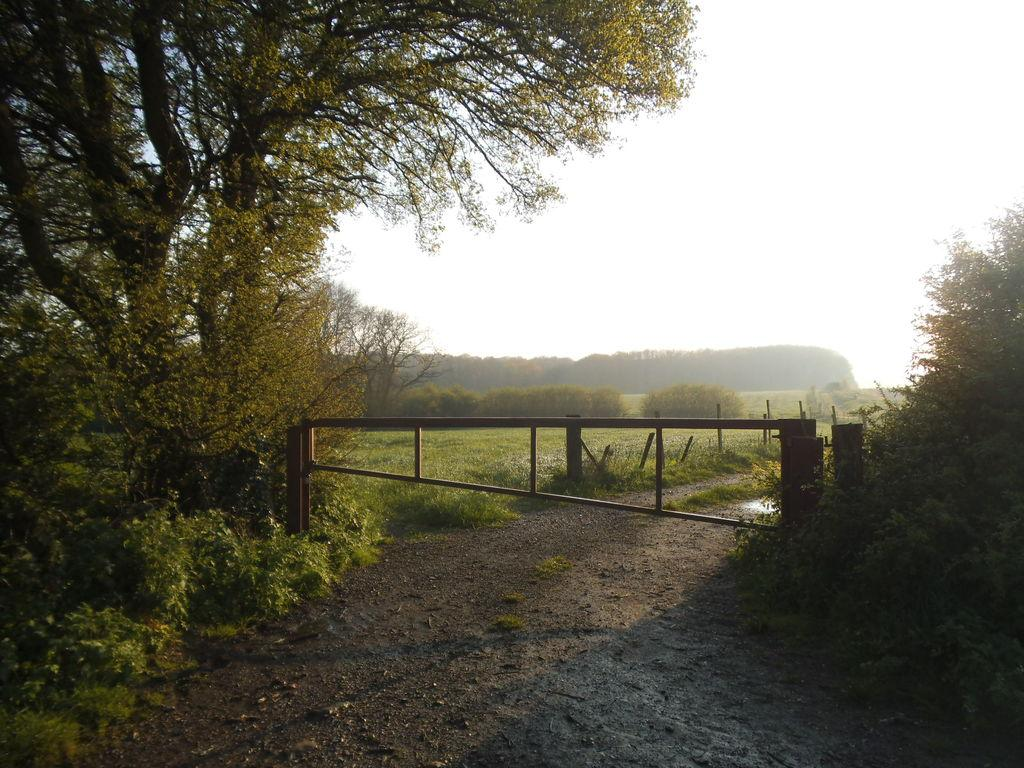What type of vegetation can be seen in the image? There are trees, shrubs, and bushes in the image. What part of the natural environment is visible in the image? The ground and the sky are visible in the image. Can you describe the vegetation in the image? The image features trees, shrubs, and bushes. What type of cushion is being used by the maid in the image? There is no maid or cushion present in the image. 